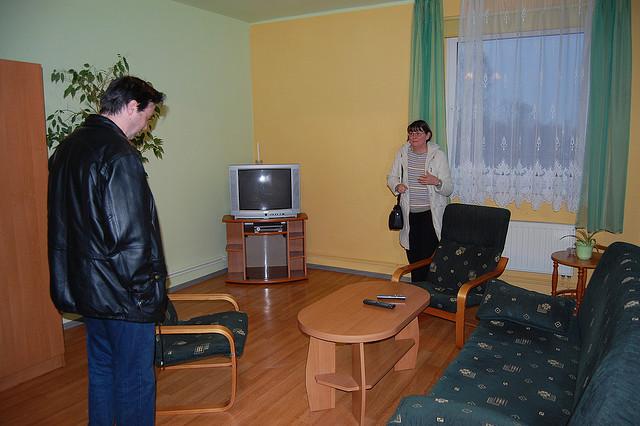What is around the woman's waist?
Quick response, please. Pants. How many bottled waters are there on the table?
Concise answer only. 0. What is the woman doing?
Keep it brief. Standing. What room is this?
Concise answer only. Living room. What is the wall behind the man, made of?
Quick response, please. Drywall. What are they looking at?
Be succinct. Table. What color is the wall to the right of the man in the leather coat?
Quick response, please. Yellow. What does the object sitting on the ground allow this man's technology to do?
Quick response, please. Sit. Is there a party going on?
Give a very brief answer. No. Is there a trash can?
Write a very short answer. No. Can you see a photograph?
Answer briefly. No. Why are they standing?
Give a very brief answer. Leaving. What kind of flowers are near the window?
Give a very brief answer. 0. What pattern is the wood on the table laid out in?
Give a very brief answer. Solid. Is this room esthetically pleasing?
Keep it brief. No. Who is speaking?
Keep it brief. Man. Is there a person in the picture?
Keep it brief. Yes. Are there people in the picture?
Write a very short answer. Yes. What is the  centerpiece made of?
Keep it brief. Wood. What material is the chair made of?
Concise answer only. Wood. What are the man doing?
Quick response, please. Standing. Is the TV flat screen?
Give a very brief answer. No. What is the likely location of this photograph?
Write a very short answer. Living room. Are these people married?
Write a very short answer. Yes. What color is the wall?
Give a very brief answer. Yellow. What are the people doing?
Give a very brief answer. Standing. 